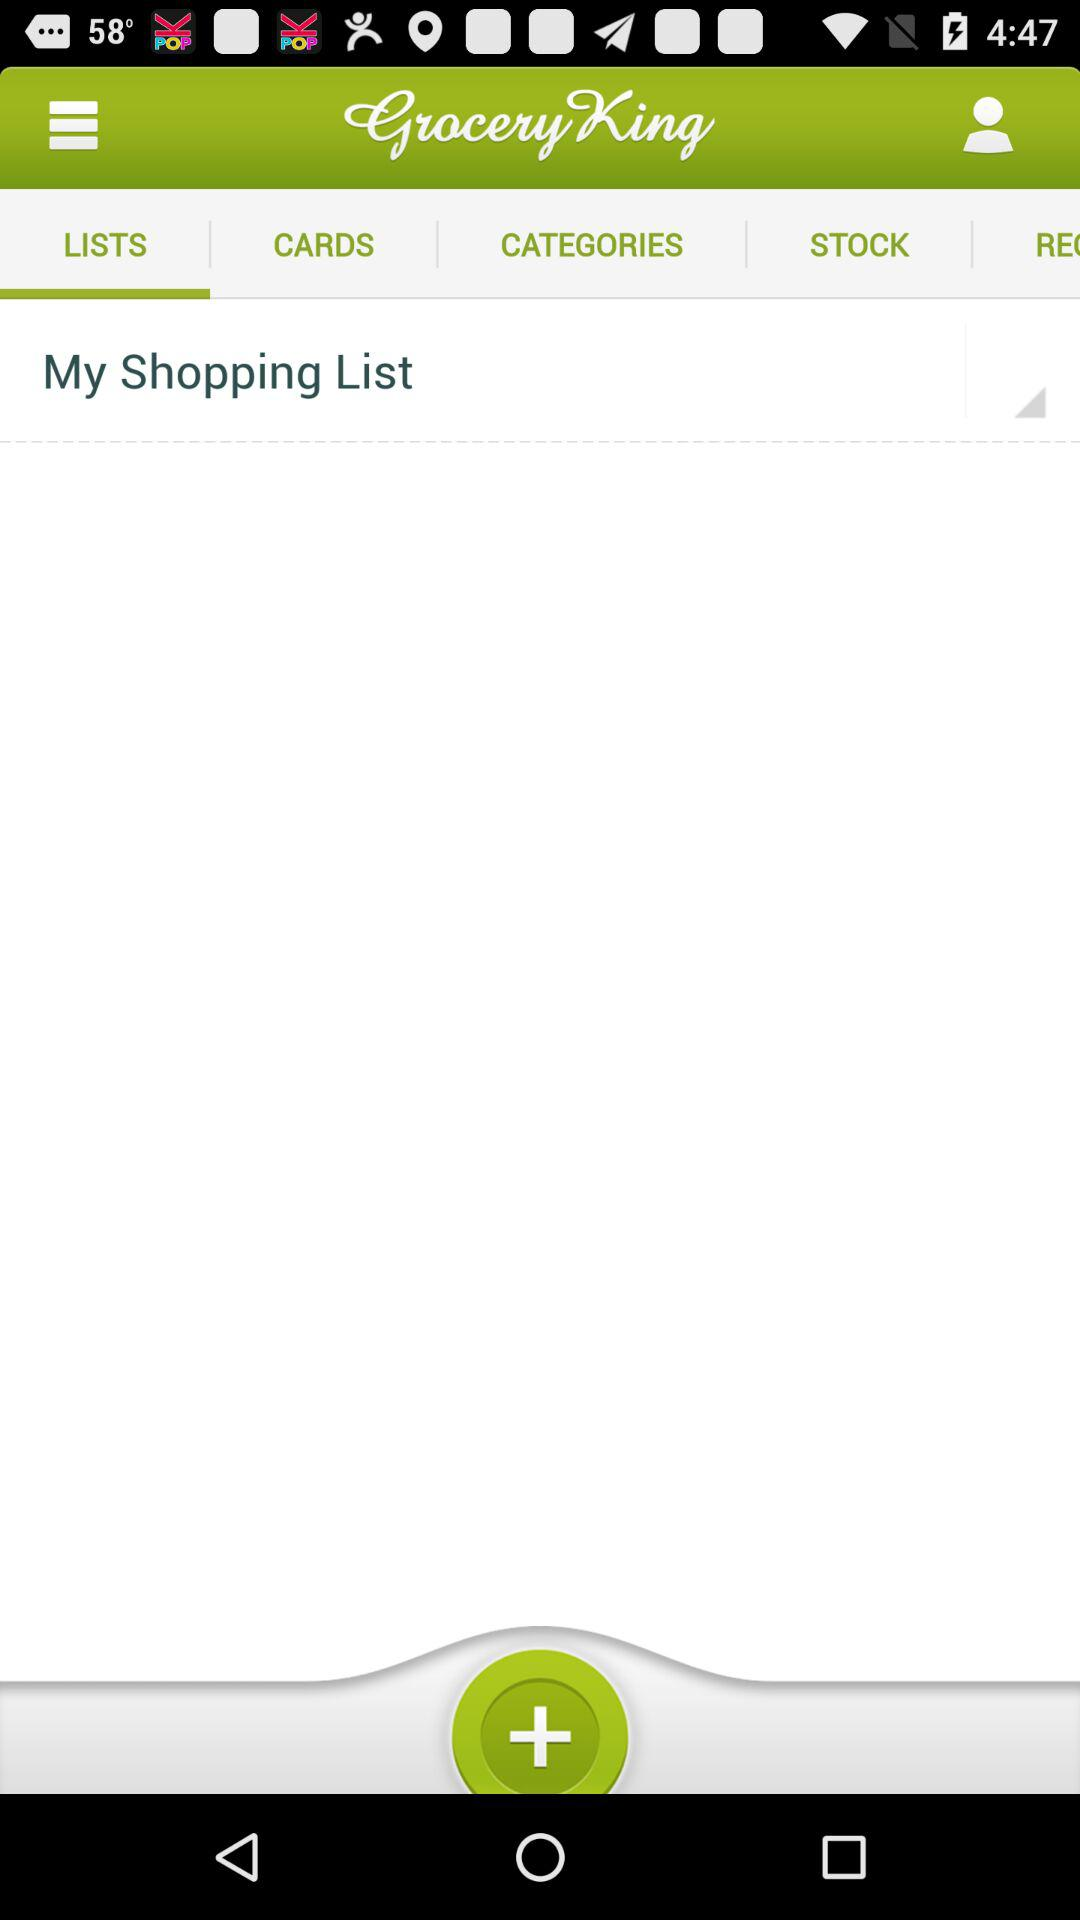Which tab am I on? You are on the "LISTS" tab. 